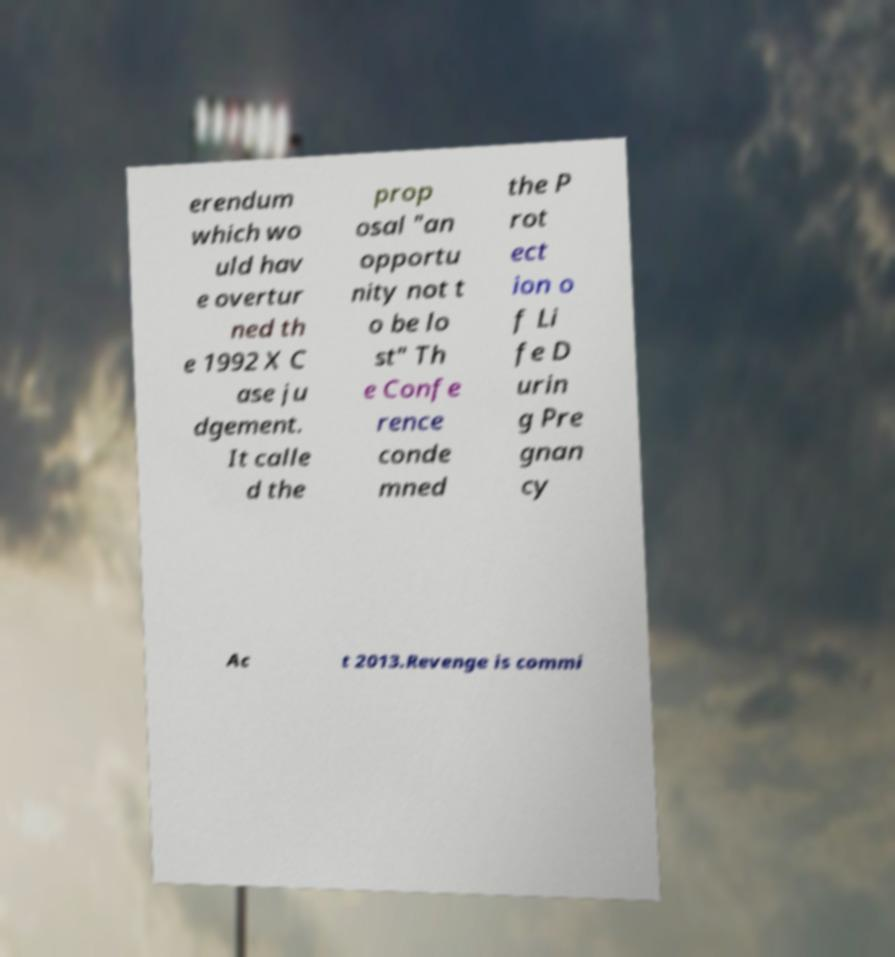I need the written content from this picture converted into text. Can you do that? erendum which wo uld hav e overtur ned th e 1992 X C ase ju dgement. It calle d the prop osal "an opportu nity not t o be lo st" Th e Confe rence conde mned the P rot ect ion o f Li fe D urin g Pre gnan cy Ac t 2013.Revenge is commi 